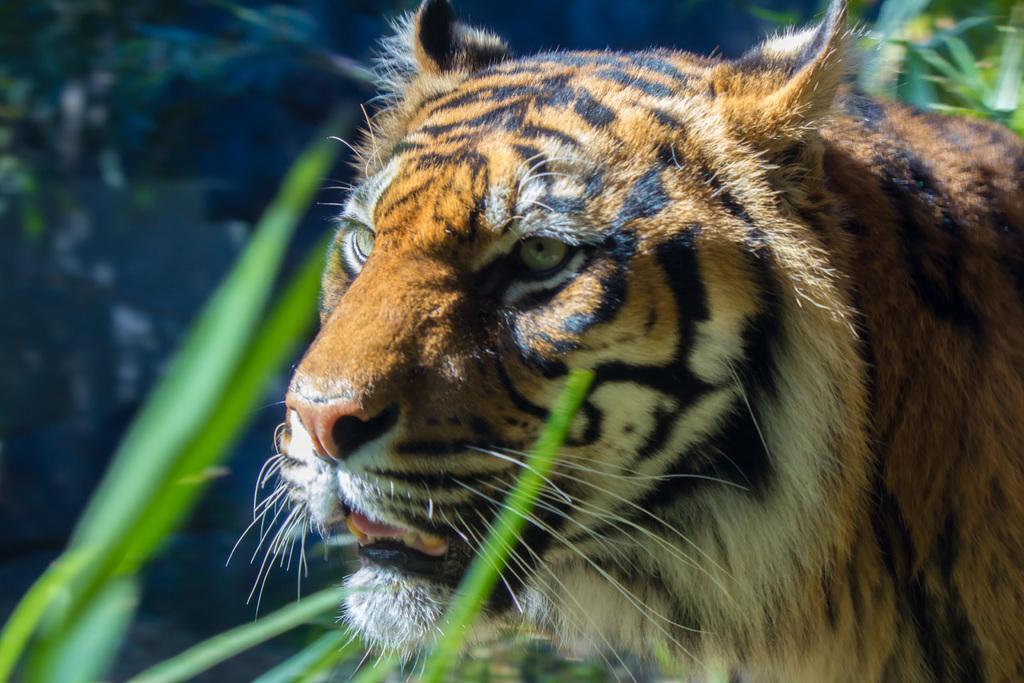Can you describe this image briefly? In the center of the image we can see a tiger. In the background there are plants. 